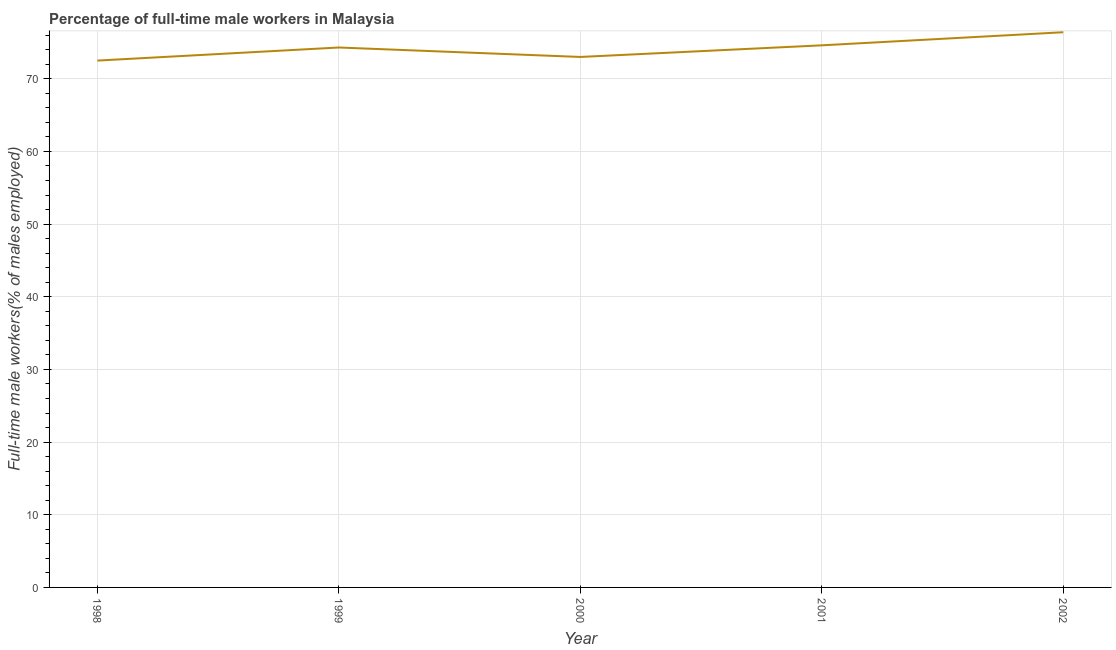What is the percentage of full-time male workers in 2002?
Give a very brief answer. 76.4. Across all years, what is the maximum percentage of full-time male workers?
Your answer should be very brief. 76.4. Across all years, what is the minimum percentage of full-time male workers?
Make the answer very short. 72.5. In which year was the percentage of full-time male workers maximum?
Give a very brief answer. 2002. In which year was the percentage of full-time male workers minimum?
Make the answer very short. 1998. What is the sum of the percentage of full-time male workers?
Your answer should be compact. 370.8. What is the average percentage of full-time male workers per year?
Provide a succinct answer. 74.16. What is the median percentage of full-time male workers?
Keep it short and to the point. 74.3. Do a majority of the years between 1998 and 2001 (inclusive) have percentage of full-time male workers greater than 10 %?
Your answer should be compact. Yes. What is the ratio of the percentage of full-time male workers in 1999 to that in 2002?
Your answer should be very brief. 0.97. What is the difference between the highest and the second highest percentage of full-time male workers?
Make the answer very short. 1.8. What is the difference between the highest and the lowest percentage of full-time male workers?
Your response must be concise. 3.9. In how many years, is the percentage of full-time male workers greater than the average percentage of full-time male workers taken over all years?
Offer a very short reply. 3. Does the percentage of full-time male workers monotonically increase over the years?
Offer a very short reply. No. How many lines are there?
Your answer should be very brief. 1. How many years are there in the graph?
Ensure brevity in your answer.  5. Does the graph contain any zero values?
Offer a terse response. No. Does the graph contain grids?
Offer a terse response. Yes. What is the title of the graph?
Provide a succinct answer. Percentage of full-time male workers in Malaysia. What is the label or title of the Y-axis?
Your answer should be very brief. Full-time male workers(% of males employed). What is the Full-time male workers(% of males employed) in 1998?
Provide a short and direct response. 72.5. What is the Full-time male workers(% of males employed) of 1999?
Provide a short and direct response. 74.3. What is the Full-time male workers(% of males employed) of 2000?
Keep it short and to the point. 73. What is the Full-time male workers(% of males employed) of 2001?
Offer a terse response. 74.6. What is the Full-time male workers(% of males employed) of 2002?
Provide a short and direct response. 76.4. What is the difference between the Full-time male workers(% of males employed) in 1998 and 1999?
Provide a short and direct response. -1.8. What is the difference between the Full-time male workers(% of males employed) in 1998 and 2002?
Provide a short and direct response. -3.9. What is the difference between the Full-time male workers(% of males employed) in 1999 and 2001?
Provide a short and direct response. -0.3. What is the difference between the Full-time male workers(% of males employed) in 1999 and 2002?
Provide a succinct answer. -2.1. What is the difference between the Full-time male workers(% of males employed) in 2000 and 2001?
Your response must be concise. -1.6. What is the difference between the Full-time male workers(% of males employed) in 2001 and 2002?
Offer a very short reply. -1.8. What is the ratio of the Full-time male workers(% of males employed) in 1998 to that in 2000?
Your answer should be compact. 0.99. What is the ratio of the Full-time male workers(% of males employed) in 1998 to that in 2001?
Keep it short and to the point. 0.97. What is the ratio of the Full-time male workers(% of males employed) in 1998 to that in 2002?
Your response must be concise. 0.95. What is the ratio of the Full-time male workers(% of males employed) in 1999 to that in 2000?
Keep it short and to the point. 1.02. What is the ratio of the Full-time male workers(% of males employed) in 2000 to that in 2002?
Offer a terse response. 0.95. What is the ratio of the Full-time male workers(% of males employed) in 2001 to that in 2002?
Offer a very short reply. 0.98. 